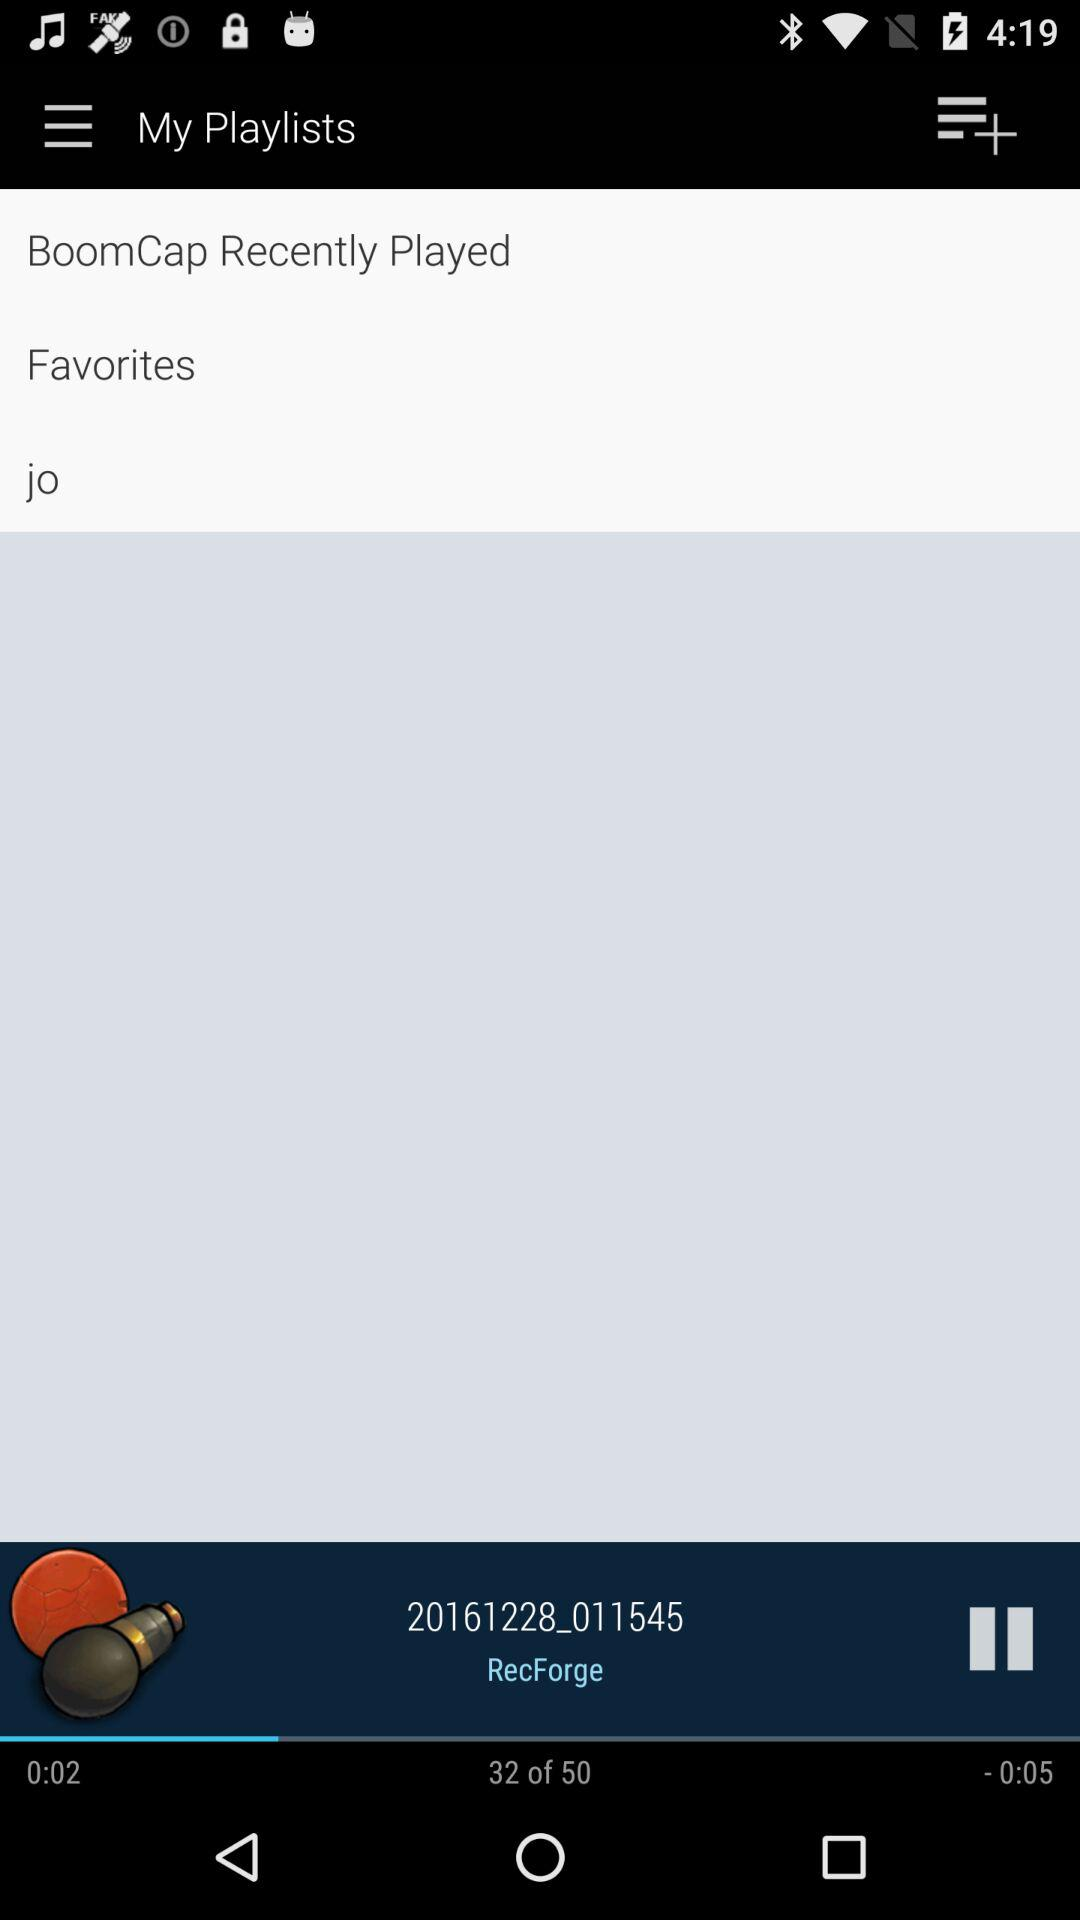What is the total number of songs? The total number of songs is 50. 